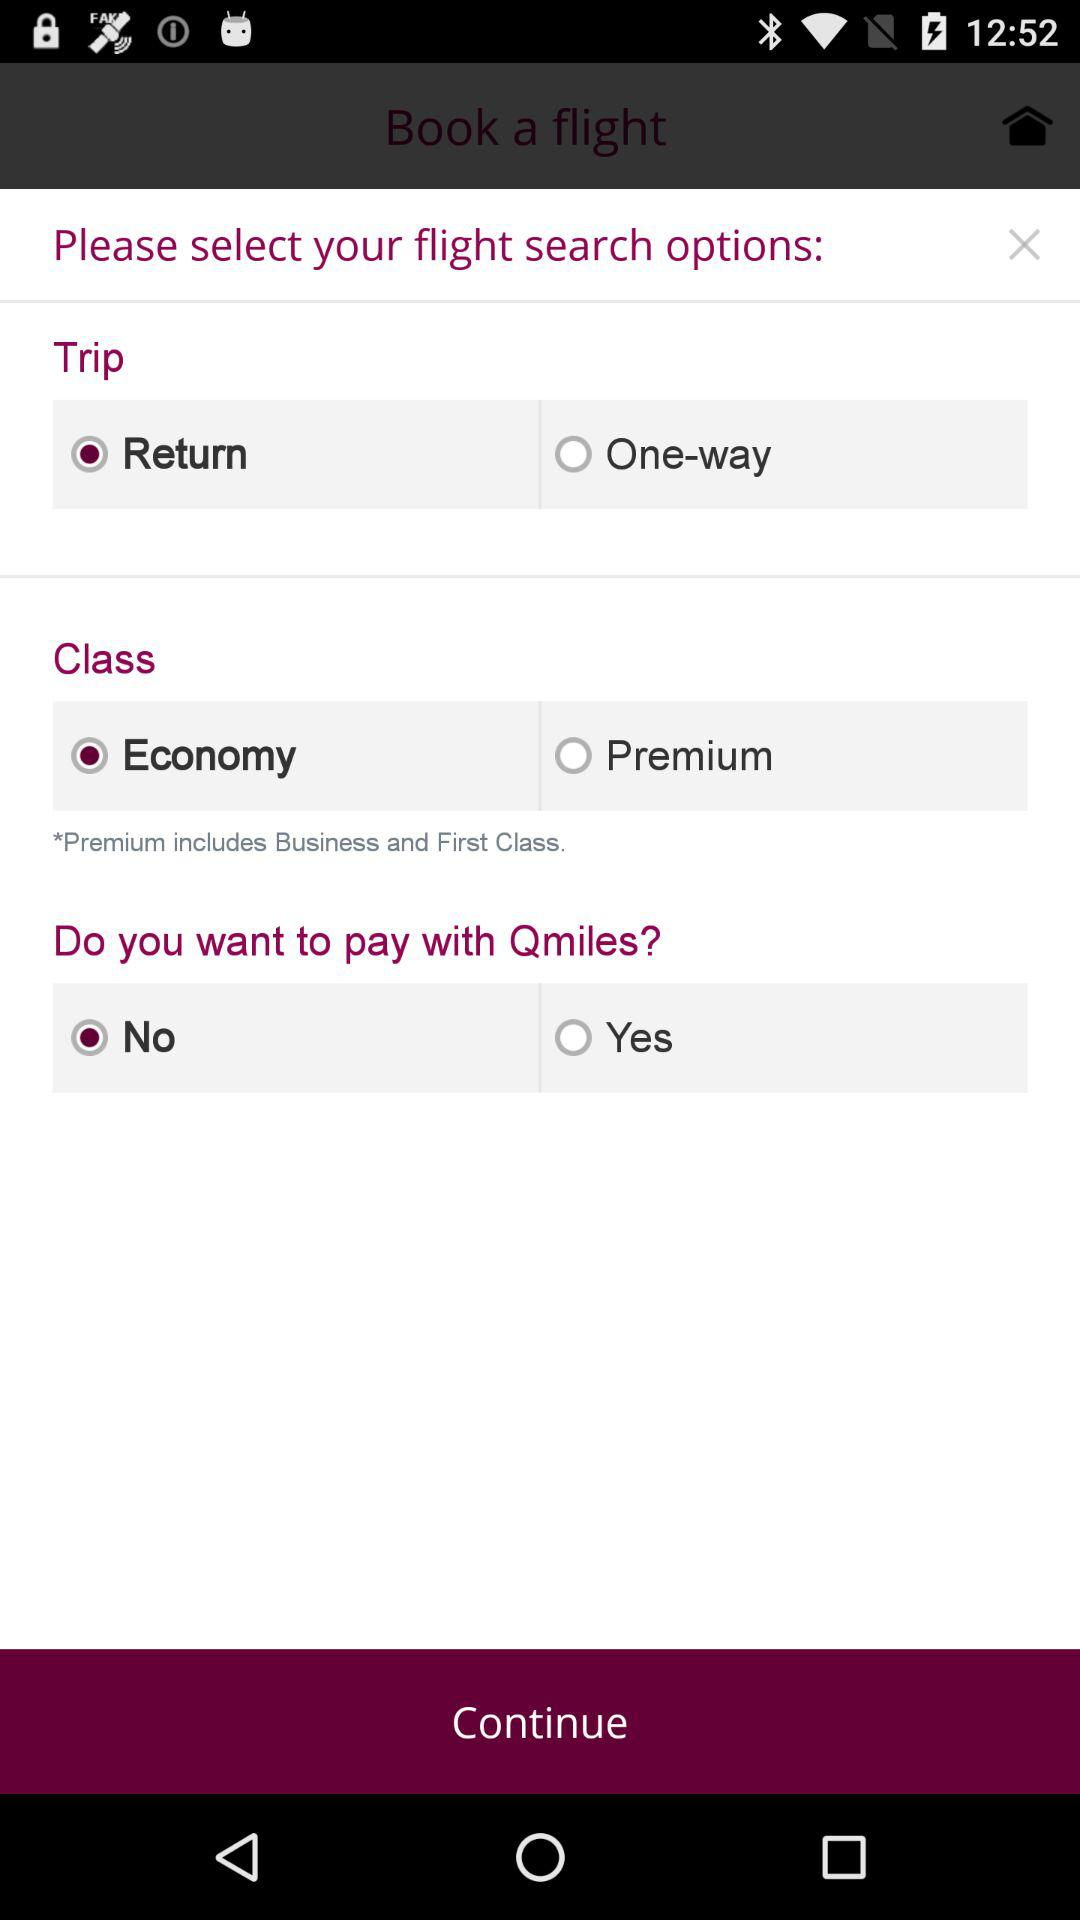What is the booked class on the flight? The booked class is economy. 